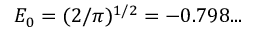Convert formula to latex. <formula><loc_0><loc_0><loc_500><loc_500>E _ { 0 } = ( 2 / \pi ) ^ { 1 / 2 } = - 0 . 7 9 8 \dots</formula> 